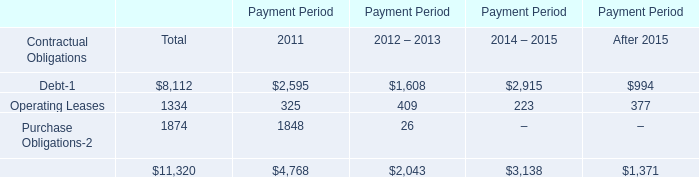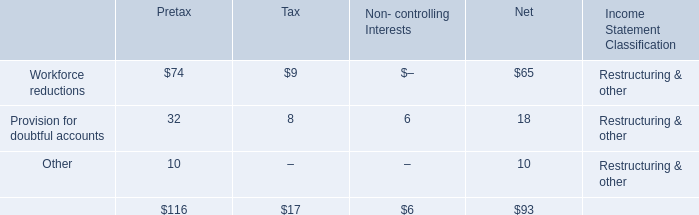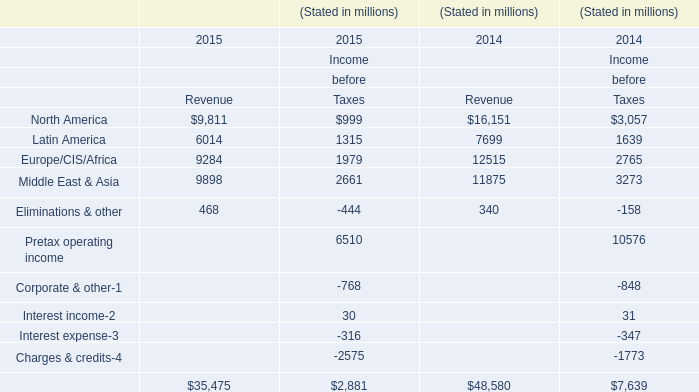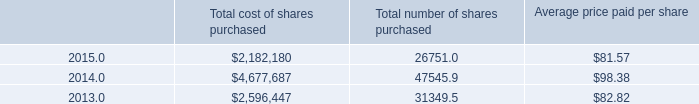What's the 20% of total elements for Revenue in 2015? (in million) 
Computations: (35475 * 0.2)
Answer: 7095.0. 